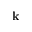Convert formula to latex. <formula><loc_0><loc_0><loc_500><loc_500>k</formula> 